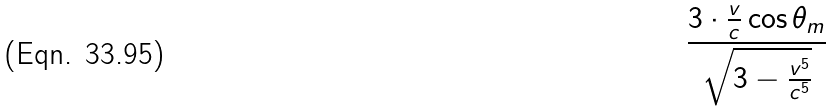Convert formula to latex. <formula><loc_0><loc_0><loc_500><loc_500>\frac { 3 \cdot \frac { v } { c } \cos \theta _ { m } } { \sqrt { 3 - \frac { v ^ { 5 } } { c ^ { 5 } } } }</formula> 